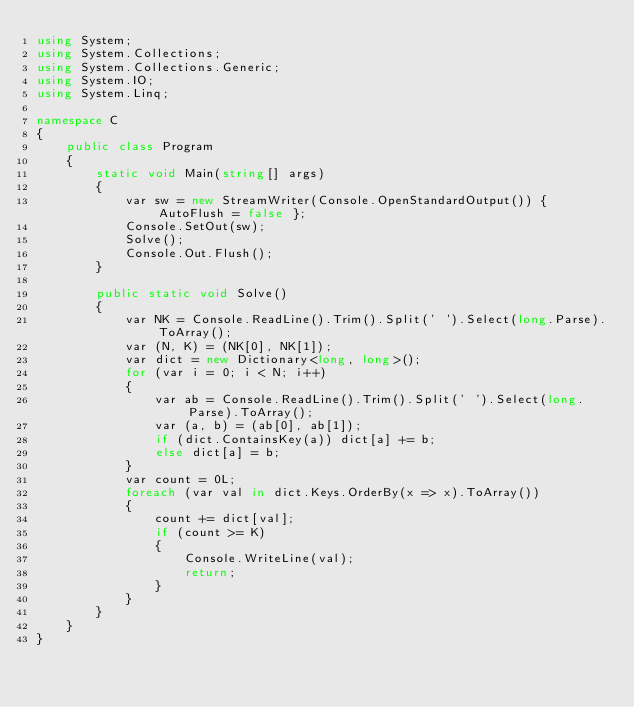<code> <loc_0><loc_0><loc_500><loc_500><_C#_>using System;
using System.Collections;
using System.Collections.Generic;
using System.IO;
using System.Linq;

namespace C
{
    public class Program
    {
        static void Main(string[] args)
        {
            var sw = new StreamWriter(Console.OpenStandardOutput()) { AutoFlush = false };
            Console.SetOut(sw);
            Solve();
            Console.Out.Flush();
        }

        public static void Solve()
        {
            var NK = Console.ReadLine().Trim().Split(' ').Select(long.Parse).ToArray();
            var (N, K) = (NK[0], NK[1]);
            var dict = new Dictionary<long, long>();
            for (var i = 0; i < N; i++)
            {
                var ab = Console.ReadLine().Trim().Split(' ').Select(long.Parse).ToArray();
                var (a, b) = (ab[0], ab[1]);
                if (dict.ContainsKey(a)) dict[a] += b;
                else dict[a] = b;
            }
            var count = 0L;
            foreach (var val in dict.Keys.OrderBy(x => x).ToArray())
            {
                count += dict[val];
                if (count >= K)
                {
                    Console.WriteLine(val);
                    return;
                }
            }
        }
    }
}
</code> 